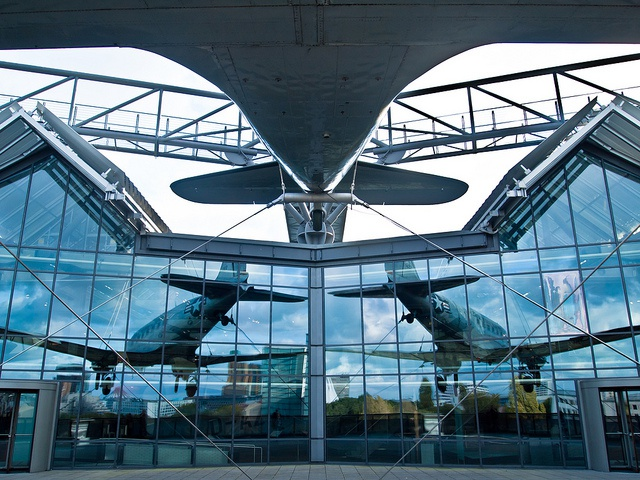Describe the objects in this image and their specific colors. I can see airplane in black, darkblue, navy, blue, and white tones, airplane in black, blue, teal, and darkblue tones, airplane in black, blue, and teal tones, and people in black, darkblue, and blue tones in this image. 